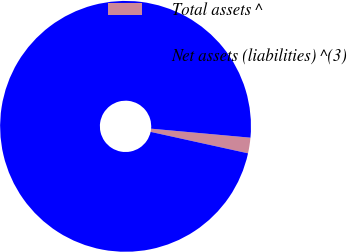<chart> <loc_0><loc_0><loc_500><loc_500><pie_chart><fcel>Total assets ^<fcel>Net assets (liabilities) ^(3)<nl><fcel>2.01%<fcel>97.99%<nl></chart> 